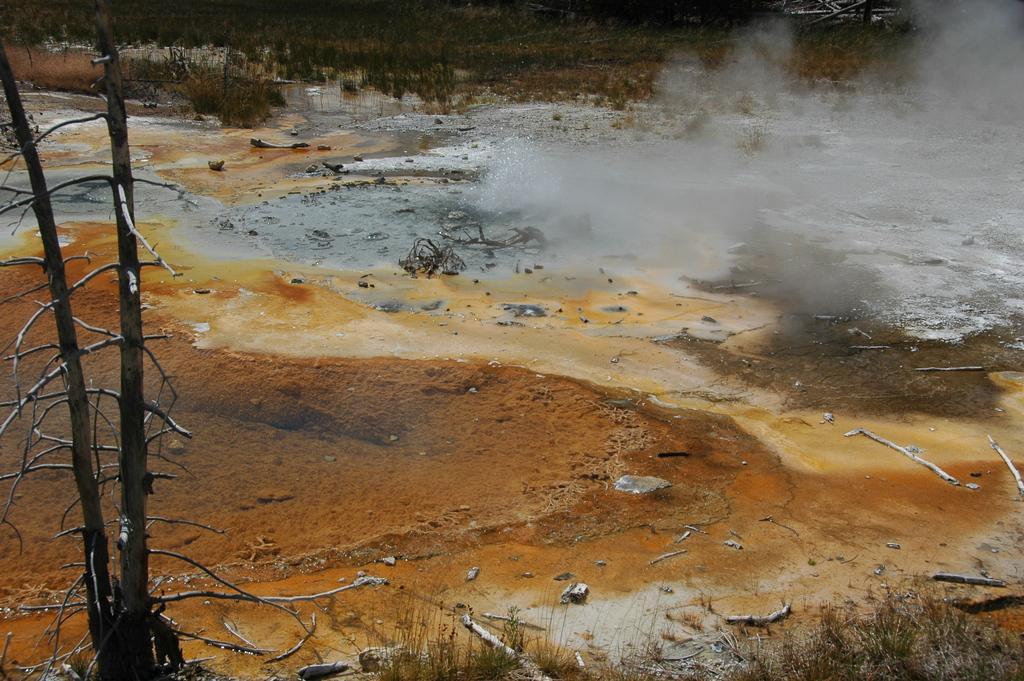In one or two sentences, can you explain what this image depicts? In this picture we can see the hot spring, trees and branches. 